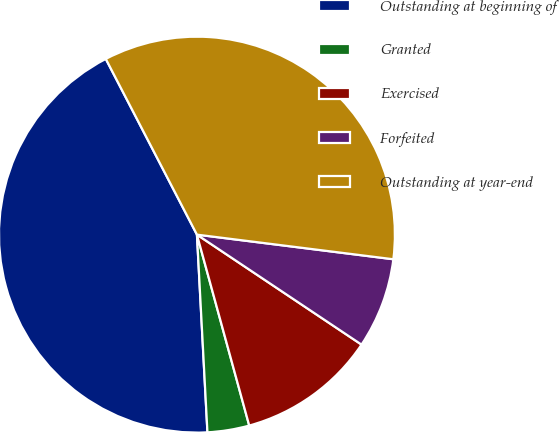Convert chart to OTSL. <chart><loc_0><loc_0><loc_500><loc_500><pie_chart><fcel>Outstanding at beginning of<fcel>Granted<fcel>Exercised<fcel>Forfeited<fcel>Outstanding at year-end<nl><fcel>43.23%<fcel>3.41%<fcel>11.37%<fcel>7.39%<fcel>34.6%<nl></chart> 